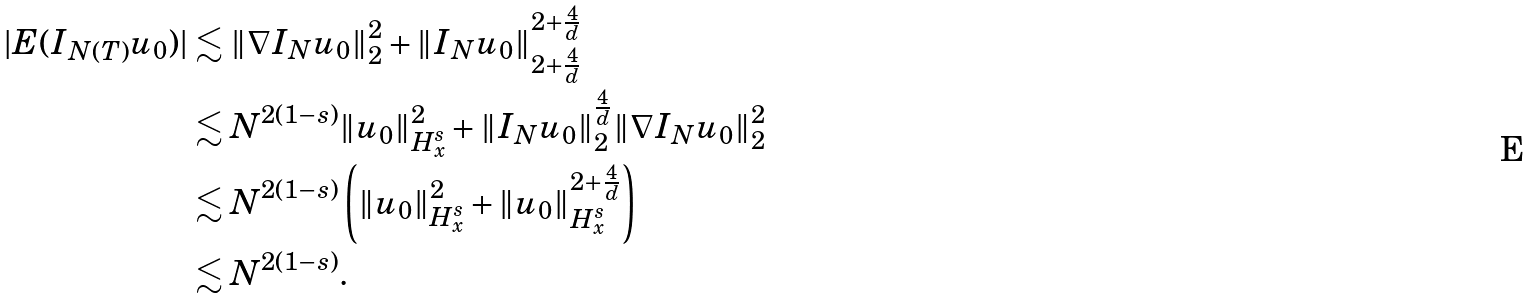Convert formula to latex. <formula><loc_0><loc_0><loc_500><loc_500>| E ( I _ { N ( T ) } u _ { 0 } ) | & \lesssim \| \nabla I _ { N } u _ { 0 } \| _ { 2 } ^ { 2 } + \| I _ { N } u _ { 0 } \| _ { 2 + \frac { 4 } { d } } ^ { 2 + \frac { 4 } { d } } \\ & \lesssim N ^ { 2 ( 1 - s ) } \| u _ { 0 } \| _ { H ^ { s } _ { x } } ^ { 2 } + \| I _ { N } u _ { 0 } \| _ { 2 } ^ { \frac { 4 } { d } } \| \nabla I _ { N } u _ { 0 } \| _ { 2 } ^ { 2 } \\ & \lesssim N ^ { 2 ( 1 - s ) } \left ( \| u _ { 0 } \| _ { H ^ { s } _ { x } } ^ { 2 } + \| u _ { 0 } \| _ { H ^ { s } _ { x } } ^ { 2 + \frac { 4 } { d } } \right ) \\ & \lesssim N ^ { 2 ( 1 - s ) } .</formula> 